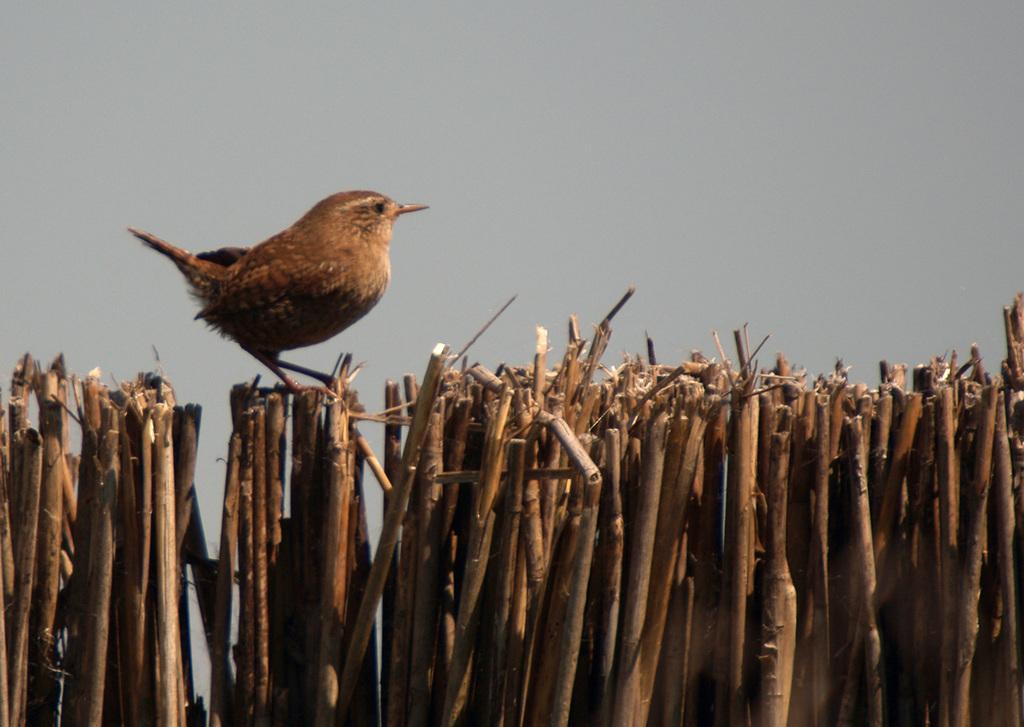Could you give a brief overview of what you see in this image? In the foreground we can see a group of wooden sticks which are placed in an order. We can also see a bird on the wooden sticks and the sky which looks cloudy. 